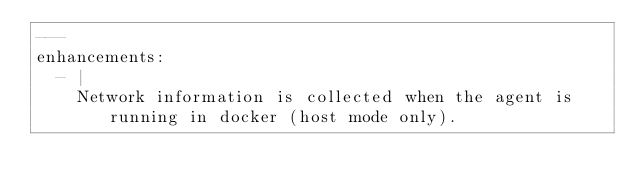<code> <loc_0><loc_0><loc_500><loc_500><_YAML_>---
enhancements:
  - |
    Network information is collected when the agent is running in docker (host mode only).
</code> 